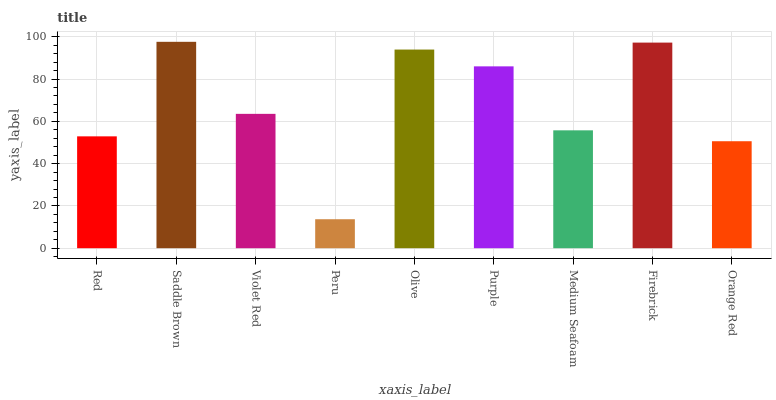Is Violet Red the minimum?
Answer yes or no. No. Is Violet Red the maximum?
Answer yes or no. No. Is Saddle Brown greater than Violet Red?
Answer yes or no. Yes. Is Violet Red less than Saddle Brown?
Answer yes or no. Yes. Is Violet Red greater than Saddle Brown?
Answer yes or no. No. Is Saddle Brown less than Violet Red?
Answer yes or no. No. Is Violet Red the high median?
Answer yes or no. Yes. Is Violet Red the low median?
Answer yes or no. Yes. Is Firebrick the high median?
Answer yes or no. No. Is Orange Red the low median?
Answer yes or no. No. 